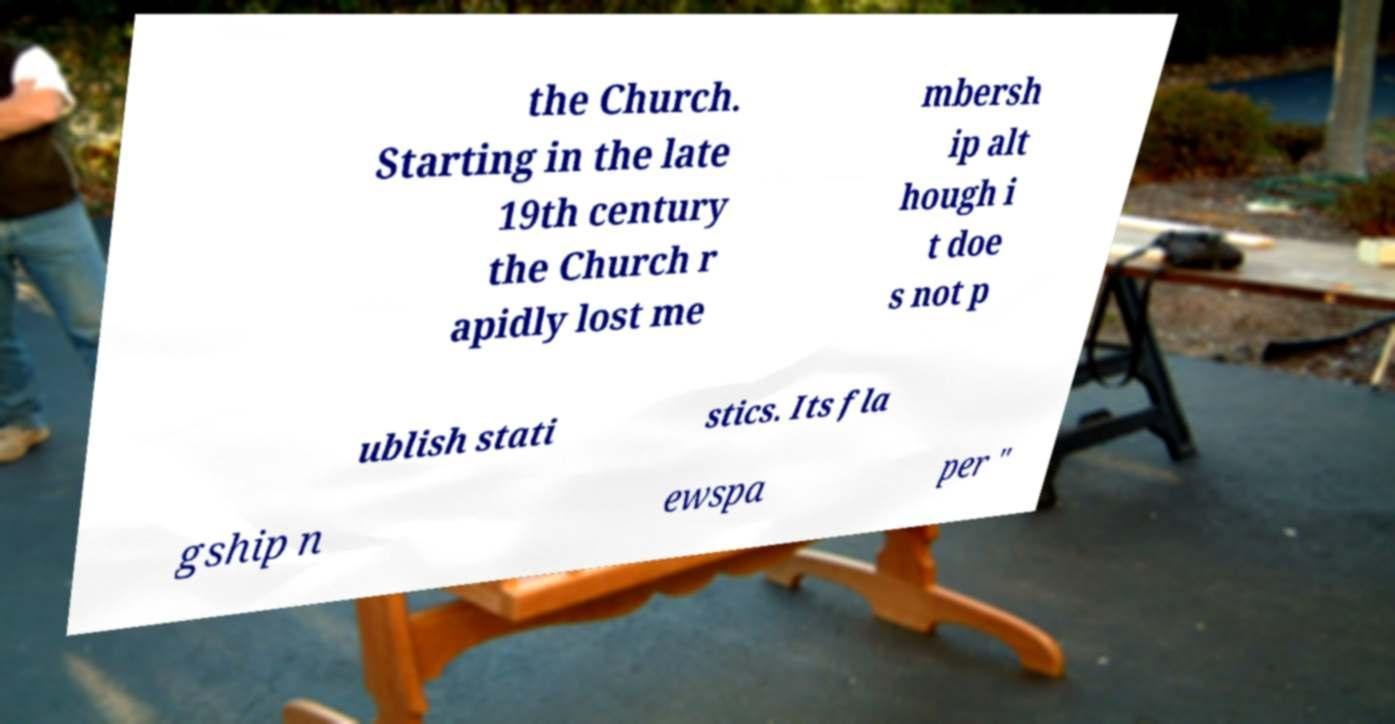Could you extract and type out the text from this image? the Church. Starting in the late 19th century the Church r apidly lost me mbersh ip alt hough i t doe s not p ublish stati stics. Its fla gship n ewspa per " 